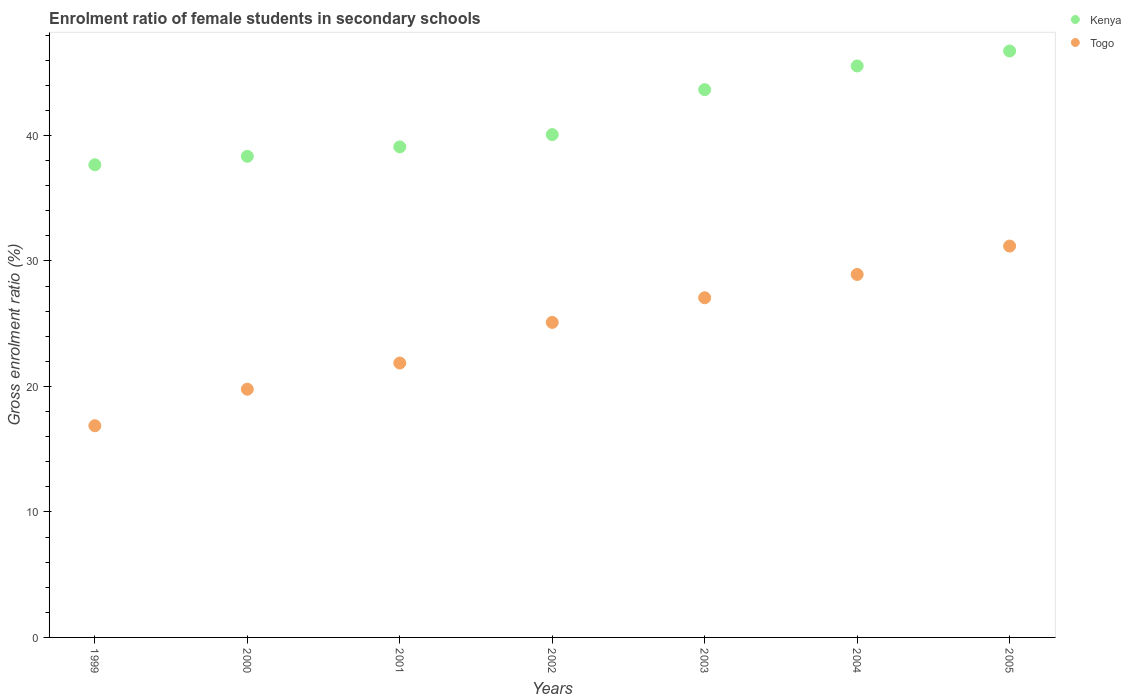How many different coloured dotlines are there?
Provide a succinct answer. 2. What is the enrolment ratio of female students in secondary schools in Togo in 2003?
Make the answer very short. 27.07. Across all years, what is the maximum enrolment ratio of female students in secondary schools in Kenya?
Your answer should be very brief. 46.74. Across all years, what is the minimum enrolment ratio of female students in secondary schools in Togo?
Your response must be concise. 16.87. In which year was the enrolment ratio of female students in secondary schools in Togo maximum?
Keep it short and to the point. 2005. In which year was the enrolment ratio of female students in secondary schools in Kenya minimum?
Provide a succinct answer. 1999. What is the total enrolment ratio of female students in secondary schools in Kenya in the graph?
Offer a very short reply. 291.1. What is the difference between the enrolment ratio of female students in secondary schools in Kenya in 2004 and that in 2005?
Offer a terse response. -1.19. What is the difference between the enrolment ratio of female students in secondary schools in Kenya in 2000 and the enrolment ratio of female students in secondary schools in Togo in 2001?
Keep it short and to the point. 16.47. What is the average enrolment ratio of female students in secondary schools in Kenya per year?
Make the answer very short. 41.59. In the year 2001, what is the difference between the enrolment ratio of female students in secondary schools in Kenya and enrolment ratio of female students in secondary schools in Togo?
Your response must be concise. 17.22. In how many years, is the enrolment ratio of female students in secondary schools in Kenya greater than 38 %?
Provide a short and direct response. 6. What is the ratio of the enrolment ratio of female students in secondary schools in Kenya in 2000 to that in 2005?
Provide a succinct answer. 0.82. Is the enrolment ratio of female students in secondary schools in Kenya in 2001 less than that in 2005?
Your answer should be compact. Yes. What is the difference between the highest and the second highest enrolment ratio of female students in secondary schools in Kenya?
Give a very brief answer. 1.19. What is the difference between the highest and the lowest enrolment ratio of female students in secondary schools in Kenya?
Your response must be concise. 9.07. In how many years, is the enrolment ratio of female students in secondary schools in Togo greater than the average enrolment ratio of female students in secondary schools in Togo taken over all years?
Your answer should be very brief. 4. Does the enrolment ratio of female students in secondary schools in Kenya monotonically increase over the years?
Ensure brevity in your answer.  Yes. How many dotlines are there?
Give a very brief answer. 2. What is the difference between two consecutive major ticks on the Y-axis?
Your answer should be very brief. 10. Are the values on the major ticks of Y-axis written in scientific E-notation?
Make the answer very short. No. Does the graph contain any zero values?
Your answer should be compact. No. Where does the legend appear in the graph?
Ensure brevity in your answer.  Top right. What is the title of the graph?
Keep it short and to the point. Enrolment ratio of female students in secondary schools. What is the label or title of the Y-axis?
Give a very brief answer. Gross enrolment ratio (%). What is the Gross enrolment ratio (%) in Kenya in 1999?
Keep it short and to the point. 37.67. What is the Gross enrolment ratio (%) in Togo in 1999?
Your answer should be very brief. 16.87. What is the Gross enrolment ratio (%) in Kenya in 2000?
Your response must be concise. 38.34. What is the Gross enrolment ratio (%) in Togo in 2000?
Give a very brief answer. 19.78. What is the Gross enrolment ratio (%) of Kenya in 2001?
Your answer should be very brief. 39.09. What is the Gross enrolment ratio (%) of Togo in 2001?
Give a very brief answer. 21.87. What is the Gross enrolment ratio (%) of Kenya in 2002?
Keep it short and to the point. 40.07. What is the Gross enrolment ratio (%) in Togo in 2002?
Offer a very short reply. 25.11. What is the Gross enrolment ratio (%) in Kenya in 2003?
Provide a succinct answer. 43.65. What is the Gross enrolment ratio (%) of Togo in 2003?
Make the answer very short. 27.07. What is the Gross enrolment ratio (%) in Kenya in 2004?
Offer a very short reply. 45.54. What is the Gross enrolment ratio (%) of Togo in 2004?
Your response must be concise. 28.93. What is the Gross enrolment ratio (%) of Kenya in 2005?
Your answer should be very brief. 46.74. What is the Gross enrolment ratio (%) of Togo in 2005?
Offer a very short reply. 31.19. Across all years, what is the maximum Gross enrolment ratio (%) in Kenya?
Offer a terse response. 46.74. Across all years, what is the maximum Gross enrolment ratio (%) of Togo?
Make the answer very short. 31.19. Across all years, what is the minimum Gross enrolment ratio (%) of Kenya?
Keep it short and to the point. 37.67. Across all years, what is the minimum Gross enrolment ratio (%) of Togo?
Your answer should be compact. 16.87. What is the total Gross enrolment ratio (%) of Kenya in the graph?
Make the answer very short. 291.1. What is the total Gross enrolment ratio (%) in Togo in the graph?
Give a very brief answer. 170.81. What is the difference between the Gross enrolment ratio (%) of Kenya in 1999 and that in 2000?
Your answer should be very brief. -0.67. What is the difference between the Gross enrolment ratio (%) in Togo in 1999 and that in 2000?
Your answer should be very brief. -2.91. What is the difference between the Gross enrolment ratio (%) of Kenya in 1999 and that in 2001?
Provide a succinct answer. -1.42. What is the difference between the Gross enrolment ratio (%) of Togo in 1999 and that in 2001?
Your answer should be compact. -5. What is the difference between the Gross enrolment ratio (%) in Kenya in 1999 and that in 2002?
Keep it short and to the point. -2.4. What is the difference between the Gross enrolment ratio (%) in Togo in 1999 and that in 2002?
Your answer should be compact. -8.24. What is the difference between the Gross enrolment ratio (%) of Kenya in 1999 and that in 2003?
Keep it short and to the point. -5.99. What is the difference between the Gross enrolment ratio (%) in Togo in 1999 and that in 2003?
Make the answer very short. -10.2. What is the difference between the Gross enrolment ratio (%) of Kenya in 1999 and that in 2004?
Your response must be concise. -7.87. What is the difference between the Gross enrolment ratio (%) of Togo in 1999 and that in 2004?
Your response must be concise. -12.05. What is the difference between the Gross enrolment ratio (%) of Kenya in 1999 and that in 2005?
Offer a terse response. -9.07. What is the difference between the Gross enrolment ratio (%) in Togo in 1999 and that in 2005?
Make the answer very short. -14.32. What is the difference between the Gross enrolment ratio (%) in Kenya in 2000 and that in 2001?
Give a very brief answer. -0.75. What is the difference between the Gross enrolment ratio (%) of Togo in 2000 and that in 2001?
Your answer should be compact. -2.09. What is the difference between the Gross enrolment ratio (%) of Kenya in 2000 and that in 2002?
Your answer should be very brief. -1.73. What is the difference between the Gross enrolment ratio (%) in Togo in 2000 and that in 2002?
Ensure brevity in your answer.  -5.33. What is the difference between the Gross enrolment ratio (%) of Kenya in 2000 and that in 2003?
Provide a succinct answer. -5.31. What is the difference between the Gross enrolment ratio (%) in Togo in 2000 and that in 2003?
Your answer should be very brief. -7.29. What is the difference between the Gross enrolment ratio (%) of Kenya in 2000 and that in 2004?
Keep it short and to the point. -7.2. What is the difference between the Gross enrolment ratio (%) of Togo in 2000 and that in 2004?
Keep it short and to the point. -9.14. What is the difference between the Gross enrolment ratio (%) of Kenya in 2000 and that in 2005?
Your answer should be compact. -8.39. What is the difference between the Gross enrolment ratio (%) in Togo in 2000 and that in 2005?
Make the answer very short. -11.41. What is the difference between the Gross enrolment ratio (%) in Kenya in 2001 and that in 2002?
Keep it short and to the point. -0.98. What is the difference between the Gross enrolment ratio (%) in Togo in 2001 and that in 2002?
Provide a short and direct response. -3.24. What is the difference between the Gross enrolment ratio (%) of Kenya in 2001 and that in 2003?
Your answer should be compact. -4.56. What is the difference between the Gross enrolment ratio (%) in Togo in 2001 and that in 2003?
Your answer should be very brief. -5.2. What is the difference between the Gross enrolment ratio (%) of Kenya in 2001 and that in 2004?
Ensure brevity in your answer.  -6.45. What is the difference between the Gross enrolment ratio (%) of Togo in 2001 and that in 2004?
Your answer should be compact. -7.06. What is the difference between the Gross enrolment ratio (%) in Kenya in 2001 and that in 2005?
Your answer should be very brief. -7.64. What is the difference between the Gross enrolment ratio (%) in Togo in 2001 and that in 2005?
Keep it short and to the point. -9.32. What is the difference between the Gross enrolment ratio (%) of Kenya in 2002 and that in 2003?
Offer a terse response. -3.58. What is the difference between the Gross enrolment ratio (%) of Togo in 2002 and that in 2003?
Your response must be concise. -1.96. What is the difference between the Gross enrolment ratio (%) in Kenya in 2002 and that in 2004?
Provide a short and direct response. -5.47. What is the difference between the Gross enrolment ratio (%) in Togo in 2002 and that in 2004?
Provide a succinct answer. -3.82. What is the difference between the Gross enrolment ratio (%) of Kenya in 2002 and that in 2005?
Keep it short and to the point. -6.66. What is the difference between the Gross enrolment ratio (%) in Togo in 2002 and that in 2005?
Give a very brief answer. -6.08. What is the difference between the Gross enrolment ratio (%) of Kenya in 2003 and that in 2004?
Ensure brevity in your answer.  -1.89. What is the difference between the Gross enrolment ratio (%) in Togo in 2003 and that in 2004?
Offer a very short reply. -1.86. What is the difference between the Gross enrolment ratio (%) in Kenya in 2003 and that in 2005?
Provide a succinct answer. -3.08. What is the difference between the Gross enrolment ratio (%) in Togo in 2003 and that in 2005?
Keep it short and to the point. -4.12. What is the difference between the Gross enrolment ratio (%) in Kenya in 2004 and that in 2005?
Offer a terse response. -1.19. What is the difference between the Gross enrolment ratio (%) in Togo in 2004 and that in 2005?
Offer a very short reply. -2.26. What is the difference between the Gross enrolment ratio (%) in Kenya in 1999 and the Gross enrolment ratio (%) in Togo in 2000?
Offer a terse response. 17.89. What is the difference between the Gross enrolment ratio (%) of Kenya in 1999 and the Gross enrolment ratio (%) of Togo in 2001?
Provide a succinct answer. 15.8. What is the difference between the Gross enrolment ratio (%) in Kenya in 1999 and the Gross enrolment ratio (%) in Togo in 2002?
Offer a very short reply. 12.56. What is the difference between the Gross enrolment ratio (%) of Kenya in 1999 and the Gross enrolment ratio (%) of Togo in 2003?
Offer a terse response. 10.6. What is the difference between the Gross enrolment ratio (%) of Kenya in 1999 and the Gross enrolment ratio (%) of Togo in 2004?
Offer a very short reply. 8.74. What is the difference between the Gross enrolment ratio (%) in Kenya in 1999 and the Gross enrolment ratio (%) in Togo in 2005?
Your answer should be compact. 6.48. What is the difference between the Gross enrolment ratio (%) of Kenya in 2000 and the Gross enrolment ratio (%) of Togo in 2001?
Keep it short and to the point. 16.47. What is the difference between the Gross enrolment ratio (%) in Kenya in 2000 and the Gross enrolment ratio (%) in Togo in 2002?
Offer a very short reply. 13.23. What is the difference between the Gross enrolment ratio (%) in Kenya in 2000 and the Gross enrolment ratio (%) in Togo in 2003?
Ensure brevity in your answer.  11.27. What is the difference between the Gross enrolment ratio (%) of Kenya in 2000 and the Gross enrolment ratio (%) of Togo in 2004?
Your answer should be compact. 9.41. What is the difference between the Gross enrolment ratio (%) in Kenya in 2000 and the Gross enrolment ratio (%) in Togo in 2005?
Give a very brief answer. 7.15. What is the difference between the Gross enrolment ratio (%) of Kenya in 2001 and the Gross enrolment ratio (%) of Togo in 2002?
Keep it short and to the point. 13.99. What is the difference between the Gross enrolment ratio (%) in Kenya in 2001 and the Gross enrolment ratio (%) in Togo in 2003?
Your response must be concise. 12.02. What is the difference between the Gross enrolment ratio (%) of Kenya in 2001 and the Gross enrolment ratio (%) of Togo in 2004?
Offer a very short reply. 10.17. What is the difference between the Gross enrolment ratio (%) of Kenya in 2001 and the Gross enrolment ratio (%) of Togo in 2005?
Give a very brief answer. 7.9. What is the difference between the Gross enrolment ratio (%) in Kenya in 2002 and the Gross enrolment ratio (%) in Togo in 2003?
Ensure brevity in your answer.  13. What is the difference between the Gross enrolment ratio (%) of Kenya in 2002 and the Gross enrolment ratio (%) of Togo in 2004?
Ensure brevity in your answer.  11.15. What is the difference between the Gross enrolment ratio (%) in Kenya in 2002 and the Gross enrolment ratio (%) in Togo in 2005?
Provide a succinct answer. 8.88. What is the difference between the Gross enrolment ratio (%) in Kenya in 2003 and the Gross enrolment ratio (%) in Togo in 2004?
Keep it short and to the point. 14.73. What is the difference between the Gross enrolment ratio (%) of Kenya in 2003 and the Gross enrolment ratio (%) of Togo in 2005?
Your answer should be very brief. 12.47. What is the difference between the Gross enrolment ratio (%) of Kenya in 2004 and the Gross enrolment ratio (%) of Togo in 2005?
Offer a very short reply. 14.35. What is the average Gross enrolment ratio (%) of Kenya per year?
Ensure brevity in your answer.  41.59. What is the average Gross enrolment ratio (%) of Togo per year?
Offer a terse response. 24.4. In the year 1999, what is the difference between the Gross enrolment ratio (%) of Kenya and Gross enrolment ratio (%) of Togo?
Provide a short and direct response. 20.8. In the year 2000, what is the difference between the Gross enrolment ratio (%) of Kenya and Gross enrolment ratio (%) of Togo?
Your answer should be very brief. 18.56. In the year 2001, what is the difference between the Gross enrolment ratio (%) of Kenya and Gross enrolment ratio (%) of Togo?
Provide a short and direct response. 17.22. In the year 2002, what is the difference between the Gross enrolment ratio (%) of Kenya and Gross enrolment ratio (%) of Togo?
Ensure brevity in your answer.  14.96. In the year 2003, what is the difference between the Gross enrolment ratio (%) in Kenya and Gross enrolment ratio (%) in Togo?
Offer a very short reply. 16.58. In the year 2004, what is the difference between the Gross enrolment ratio (%) of Kenya and Gross enrolment ratio (%) of Togo?
Offer a very short reply. 16.62. In the year 2005, what is the difference between the Gross enrolment ratio (%) of Kenya and Gross enrolment ratio (%) of Togo?
Your response must be concise. 15.55. What is the ratio of the Gross enrolment ratio (%) of Kenya in 1999 to that in 2000?
Keep it short and to the point. 0.98. What is the ratio of the Gross enrolment ratio (%) of Togo in 1999 to that in 2000?
Your answer should be very brief. 0.85. What is the ratio of the Gross enrolment ratio (%) of Kenya in 1999 to that in 2001?
Your answer should be very brief. 0.96. What is the ratio of the Gross enrolment ratio (%) of Togo in 1999 to that in 2001?
Offer a very short reply. 0.77. What is the ratio of the Gross enrolment ratio (%) in Togo in 1999 to that in 2002?
Offer a terse response. 0.67. What is the ratio of the Gross enrolment ratio (%) of Kenya in 1999 to that in 2003?
Provide a succinct answer. 0.86. What is the ratio of the Gross enrolment ratio (%) in Togo in 1999 to that in 2003?
Your answer should be compact. 0.62. What is the ratio of the Gross enrolment ratio (%) in Kenya in 1999 to that in 2004?
Ensure brevity in your answer.  0.83. What is the ratio of the Gross enrolment ratio (%) of Togo in 1999 to that in 2004?
Offer a very short reply. 0.58. What is the ratio of the Gross enrolment ratio (%) of Kenya in 1999 to that in 2005?
Offer a very short reply. 0.81. What is the ratio of the Gross enrolment ratio (%) of Togo in 1999 to that in 2005?
Provide a short and direct response. 0.54. What is the ratio of the Gross enrolment ratio (%) in Kenya in 2000 to that in 2001?
Give a very brief answer. 0.98. What is the ratio of the Gross enrolment ratio (%) of Togo in 2000 to that in 2001?
Provide a succinct answer. 0.9. What is the ratio of the Gross enrolment ratio (%) of Kenya in 2000 to that in 2002?
Your answer should be compact. 0.96. What is the ratio of the Gross enrolment ratio (%) in Togo in 2000 to that in 2002?
Provide a succinct answer. 0.79. What is the ratio of the Gross enrolment ratio (%) in Kenya in 2000 to that in 2003?
Give a very brief answer. 0.88. What is the ratio of the Gross enrolment ratio (%) in Togo in 2000 to that in 2003?
Give a very brief answer. 0.73. What is the ratio of the Gross enrolment ratio (%) of Kenya in 2000 to that in 2004?
Your answer should be very brief. 0.84. What is the ratio of the Gross enrolment ratio (%) in Togo in 2000 to that in 2004?
Your answer should be compact. 0.68. What is the ratio of the Gross enrolment ratio (%) in Kenya in 2000 to that in 2005?
Provide a succinct answer. 0.82. What is the ratio of the Gross enrolment ratio (%) in Togo in 2000 to that in 2005?
Your answer should be very brief. 0.63. What is the ratio of the Gross enrolment ratio (%) in Kenya in 2001 to that in 2002?
Give a very brief answer. 0.98. What is the ratio of the Gross enrolment ratio (%) in Togo in 2001 to that in 2002?
Offer a very short reply. 0.87. What is the ratio of the Gross enrolment ratio (%) in Kenya in 2001 to that in 2003?
Provide a short and direct response. 0.9. What is the ratio of the Gross enrolment ratio (%) in Togo in 2001 to that in 2003?
Provide a short and direct response. 0.81. What is the ratio of the Gross enrolment ratio (%) in Kenya in 2001 to that in 2004?
Give a very brief answer. 0.86. What is the ratio of the Gross enrolment ratio (%) of Togo in 2001 to that in 2004?
Provide a succinct answer. 0.76. What is the ratio of the Gross enrolment ratio (%) in Kenya in 2001 to that in 2005?
Your response must be concise. 0.84. What is the ratio of the Gross enrolment ratio (%) in Togo in 2001 to that in 2005?
Your response must be concise. 0.7. What is the ratio of the Gross enrolment ratio (%) of Kenya in 2002 to that in 2003?
Give a very brief answer. 0.92. What is the ratio of the Gross enrolment ratio (%) of Togo in 2002 to that in 2003?
Ensure brevity in your answer.  0.93. What is the ratio of the Gross enrolment ratio (%) in Kenya in 2002 to that in 2004?
Ensure brevity in your answer.  0.88. What is the ratio of the Gross enrolment ratio (%) in Togo in 2002 to that in 2004?
Offer a terse response. 0.87. What is the ratio of the Gross enrolment ratio (%) of Kenya in 2002 to that in 2005?
Ensure brevity in your answer.  0.86. What is the ratio of the Gross enrolment ratio (%) in Togo in 2002 to that in 2005?
Provide a succinct answer. 0.81. What is the ratio of the Gross enrolment ratio (%) in Kenya in 2003 to that in 2004?
Provide a short and direct response. 0.96. What is the ratio of the Gross enrolment ratio (%) in Togo in 2003 to that in 2004?
Your answer should be compact. 0.94. What is the ratio of the Gross enrolment ratio (%) of Kenya in 2003 to that in 2005?
Your answer should be very brief. 0.93. What is the ratio of the Gross enrolment ratio (%) of Togo in 2003 to that in 2005?
Keep it short and to the point. 0.87. What is the ratio of the Gross enrolment ratio (%) in Kenya in 2004 to that in 2005?
Your answer should be very brief. 0.97. What is the ratio of the Gross enrolment ratio (%) in Togo in 2004 to that in 2005?
Offer a terse response. 0.93. What is the difference between the highest and the second highest Gross enrolment ratio (%) in Kenya?
Give a very brief answer. 1.19. What is the difference between the highest and the second highest Gross enrolment ratio (%) in Togo?
Ensure brevity in your answer.  2.26. What is the difference between the highest and the lowest Gross enrolment ratio (%) in Kenya?
Provide a succinct answer. 9.07. What is the difference between the highest and the lowest Gross enrolment ratio (%) in Togo?
Provide a succinct answer. 14.32. 